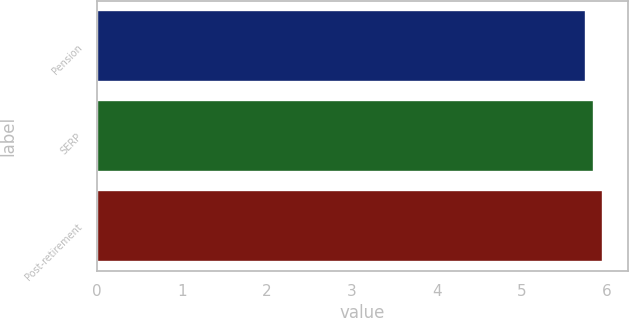Convert chart. <chart><loc_0><loc_0><loc_500><loc_500><bar_chart><fcel>Pension<fcel>SERP<fcel>Post-retirement<nl><fcel>5.75<fcel>5.85<fcel>5.95<nl></chart> 